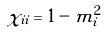<formula> <loc_0><loc_0><loc_500><loc_500>\chi _ { i i } = 1 - m _ { i } ^ { 2 }</formula> 